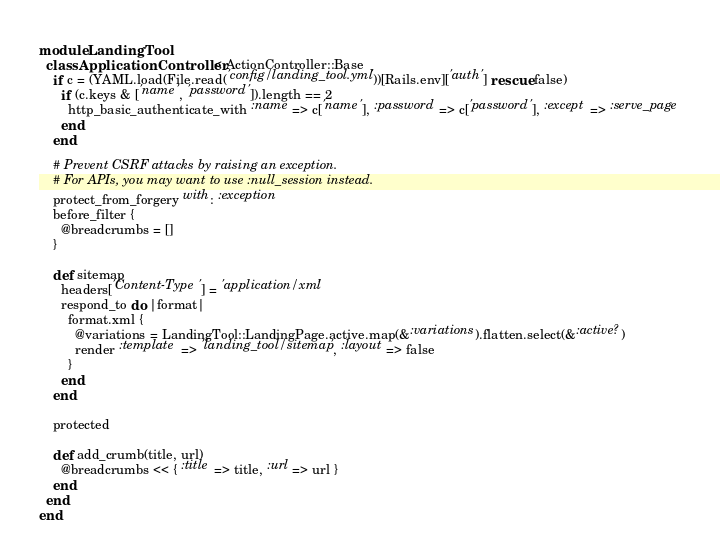<code> <loc_0><loc_0><loc_500><loc_500><_Ruby_>module LandingTool
  class ApplicationController < ActionController::Base
    if c = (YAML.load(File.read('config/landing_tool.yml'))[Rails.env]['auth'] rescue false)
      if (c.keys & ['name', 'password']).length == 2
        http_basic_authenticate_with :name => c['name'], :password => c['password'], :except => :serve_page
      end
    end

    # Prevent CSRF attacks by raising an exception.
    # For APIs, you may want to use :null_session instead.
    protect_from_forgery with: :exception
    before_filter {
      @breadcrumbs = []
    }

    def sitemap
      headers['Content-Type'] = 'application/xml'
      respond_to do |format|
        format.xml {
          @variations = LandingTool::LandingPage.active.map(&:variations).flatten.select(&:active?)
          render :template => 'landing_tool/sitemap', :layout => false
        }
      end
    end

    protected

    def add_crumb(title, url)
      @breadcrumbs << { :title => title, :url => url }
    end
  end
end
</code> 